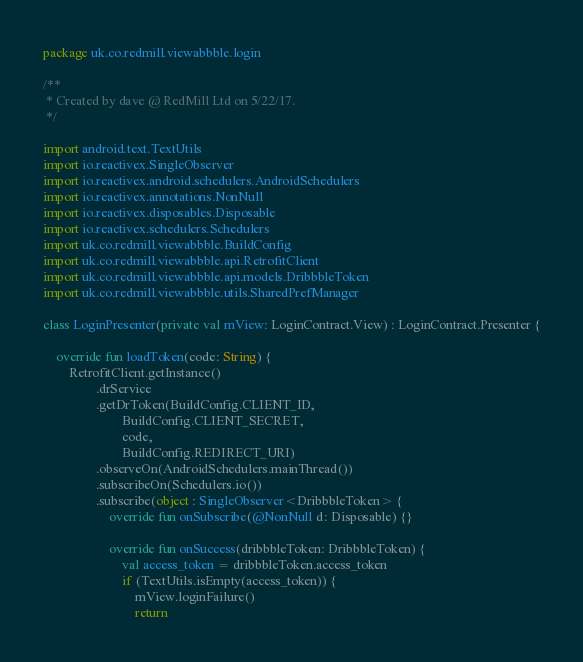<code> <loc_0><loc_0><loc_500><loc_500><_Kotlin_>package uk.co.redmill.viewabbble.login

/**
 * Created by dave @ RedMill Ltd on 5/22/17.
 */

import android.text.TextUtils
import io.reactivex.SingleObserver
import io.reactivex.android.schedulers.AndroidSchedulers
import io.reactivex.annotations.NonNull
import io.reactivex.disposables.Disposable
import io.reactivex.schedulers.Schedulers
import uk.co.redmill.viewabbble.BuildConfig
import uk.co.redmill.viewabbble.api.RetrofitClient
import uk.co.redmill.viewabbble.api.models.DribbbleToken
import uk.co.redmill.viewabbble.utils.SharedPrefManager

class LoginPresenter(private val mView: LoginContract.View) : LoginContract.Presenter {

    override fun loadToken(code: String) {
        RetrofitClient.getInstance()
                .drService
                .getDrToken(BuildConfig.CLIENT_ID,
                        BuildConfig.CLIENT_SECRET,
                        code,
                        BuildConfig.REDIRECT_URI)
                .observeOn(AndroidSchedulers.mainThread())
                .subscribeOn(Schedulers.io())
                .subscribe(object : SingleObserver<DribbbleToken> {
                    override fun onSubscribe(@NonNull d: Disposable) {}

                    override fun onSuccess(dribbbleToken: DribbbleToken) {
                        val access_token = dribbbleToken.access_token
                        if (TextUtils.isEmpty(access_token)) {
                            mView.loginFailure()
                            return</code> 